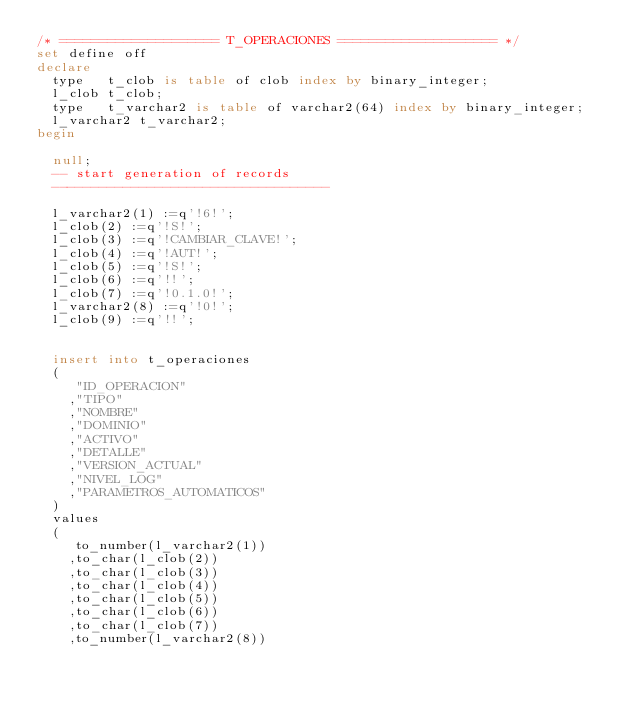<code> <loc_0><loc_0><loc_500><loc_500><_SQL_>/* ==================== T_OPERACIONES ==================== */
set define off
declare
  type   t_clob is table of clob index by binary_integer;
  l_clob t_clob;
  type   t_varchar2 is table of varchar2(64) index by binary_integer;
  l_varchar2 t_varchar2;
begin

  null;
  -- start generation of records
  -----------------------------------

  l_varchar2(1) :=q'!6!';
  l_clob(2) :=q'!S!';
  l_clob(3) :=q'!CAMBIAR_CLAVE!';
  l_clob(4) :=q'!AUT!';
  l_clob(5) :=q'!S!';
  l_clob(6) :=q'!!';
  l_clob(7) :=q'!0.1.0!';
  l_varchar2(8) :=q'!0!';
  l_clob(9) :=q'!!';

  insert into t_operaciones
  (
     "ID_OPERACION"
    ,"TIPO"
    ,"NOMBRE"
    ,"DOMINIO"
    ,"ACTIVO"
    ,"DETALLE"
    ,"VERSION_ACTUAL"
    ,"NIVEL_LOG"
    ,"PARAMETROS_AUTOMATICOS"
  )
  values
  (
     to_number(l_varchar2(1))
    ,to_char(l_clob(2))
    ,to_char(l_clob(3))
    ,to_char(l_clob(4))
    ,to_char(l_clob(5))
    ,to_char(l_clob(6))
    ,to_char(l_clob(7))
    ,to_number(l_varchar2(8))</code> 